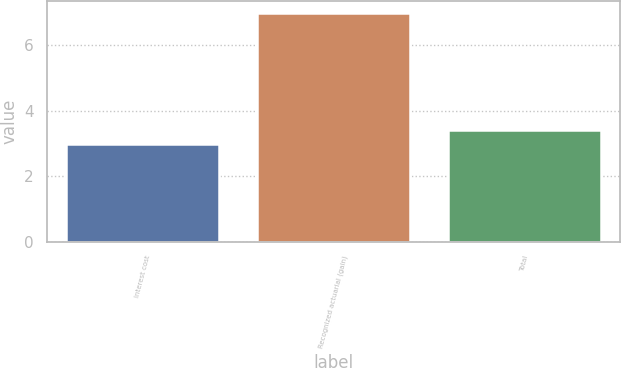Convert chart to OTSL. <chart><loc_0><loc_0><loc_500><loc_500><bar_chart><fcel>Interest cost<fcel>Recognized actuarial (gain)<fcel>Total<nl><fcel>3<fcel>7<fcel>3.4<nl></chart> 